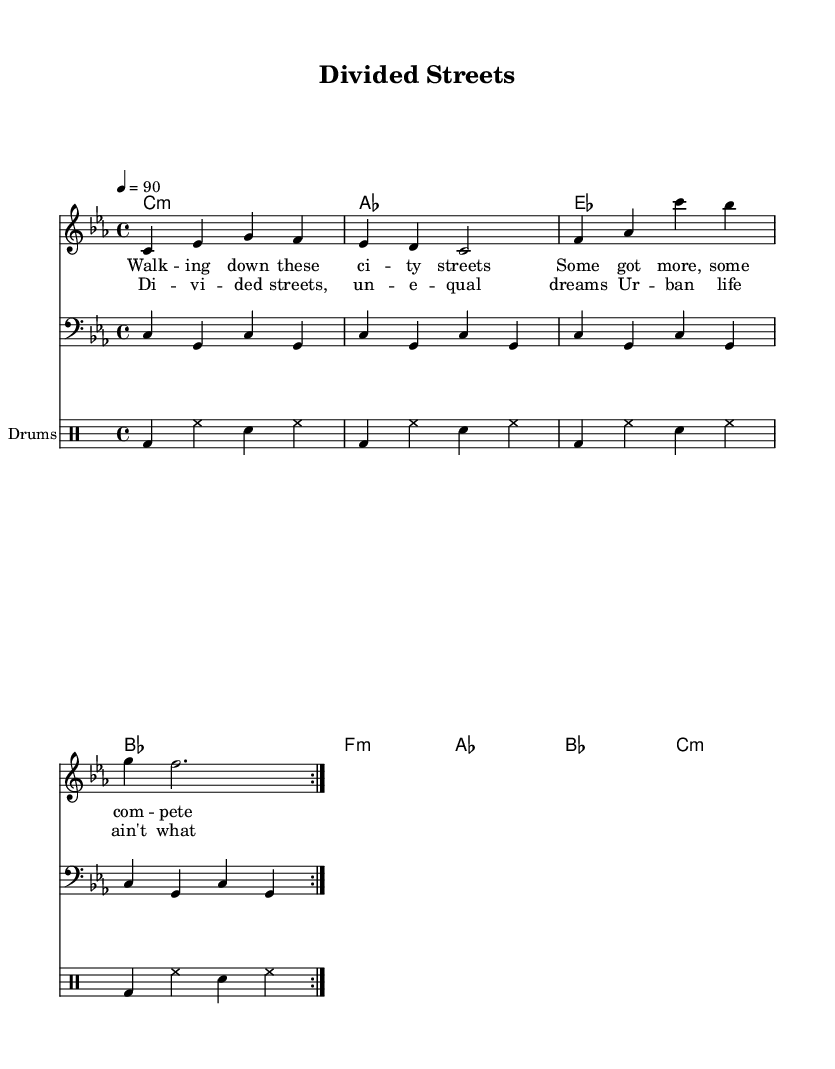What is the key signature of this music? The key signature is indicated at the beginning of the staff. It is C minor, which has three flats.
Answer: C minor What is the time signature of this piece? The time signature appears prominently at the beginning and indicates how many beats are in each measure. The time signature is 4/4, which means there are four beats per measure.
Answer: 4/4 What is the tempo marking for this song? The tempo marking is shown at the beginning of the score, specifying how fast the piece should be played. It is marked as "4 = 90", which indicates 90 beats per minute.
Answer: 90 How many measures are in the repeated section of the melody? The notation shows the melody section marked with "repeat volta 2", implying it is to be played twice. Each iteration has four measures, making it total eight measures in this repeated part.
Answer: 8 What is the first lyric line of the verse? The first line of lyrics is placed under the melody and can be clearly read. It begins with "Walking down these city streets".
Answer: Walking down these city streets What is the chord progression for the chorus section? To determine the chord progression, examine the chord symbols placed above the lyrics. The progression for the chorus is denoted by the chords: E flat, A flat, B flat, and C minor.
Answer: E flat, A flat, B flat, C minor What type of rhythmic pattern is used in the drum section? The drum section, indicated in the drummode, shows a pattern consisting of bass drum and snare hits interspersed with hi-hat cymbals. This pattern is repeated in the measures and creates a syncopated rhythm characteristic of R&B.
Answer: Bass drum and snare with hi-hat 